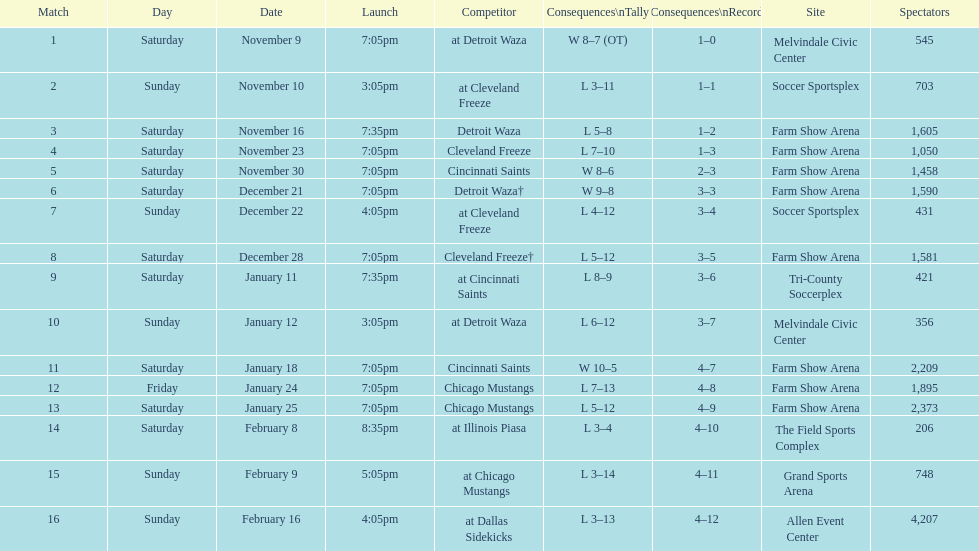Who was the first opponent on this list? Detroit Waza. 